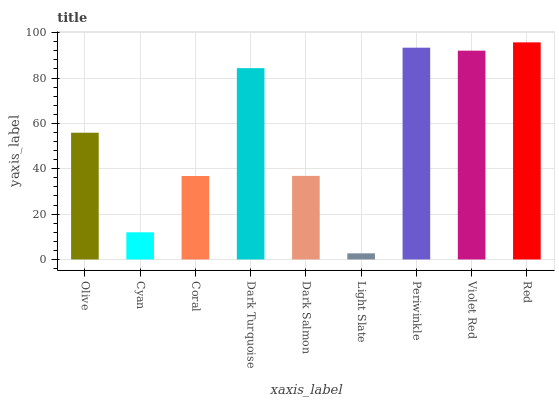Is Light Slate the minimum?
Answer yes or no. Yes. Is Red the maximum?
Answer yes or no. Yes. Is Cyan the minimum?
Answer yes or no. No. Is Cyan the maximum?
Answer yes or no. No. Is Olive greater than Cyan?
Answer yes or no. Yes. Is Cyan less than Olive?
Answer yes or no. Yes. Is Cyan greater than Olive?
Answer yes or no. No. Is Olive less than Cyan?
Answer yes or no. No. Is Olive the high median?
Answer yes or no. Yes. Is Olive the low median?
Answer yes or no. Yes. Is Red the high median?
Answer yes or no. No. Is Violet Red the low median?
Answer yes or no. No. 